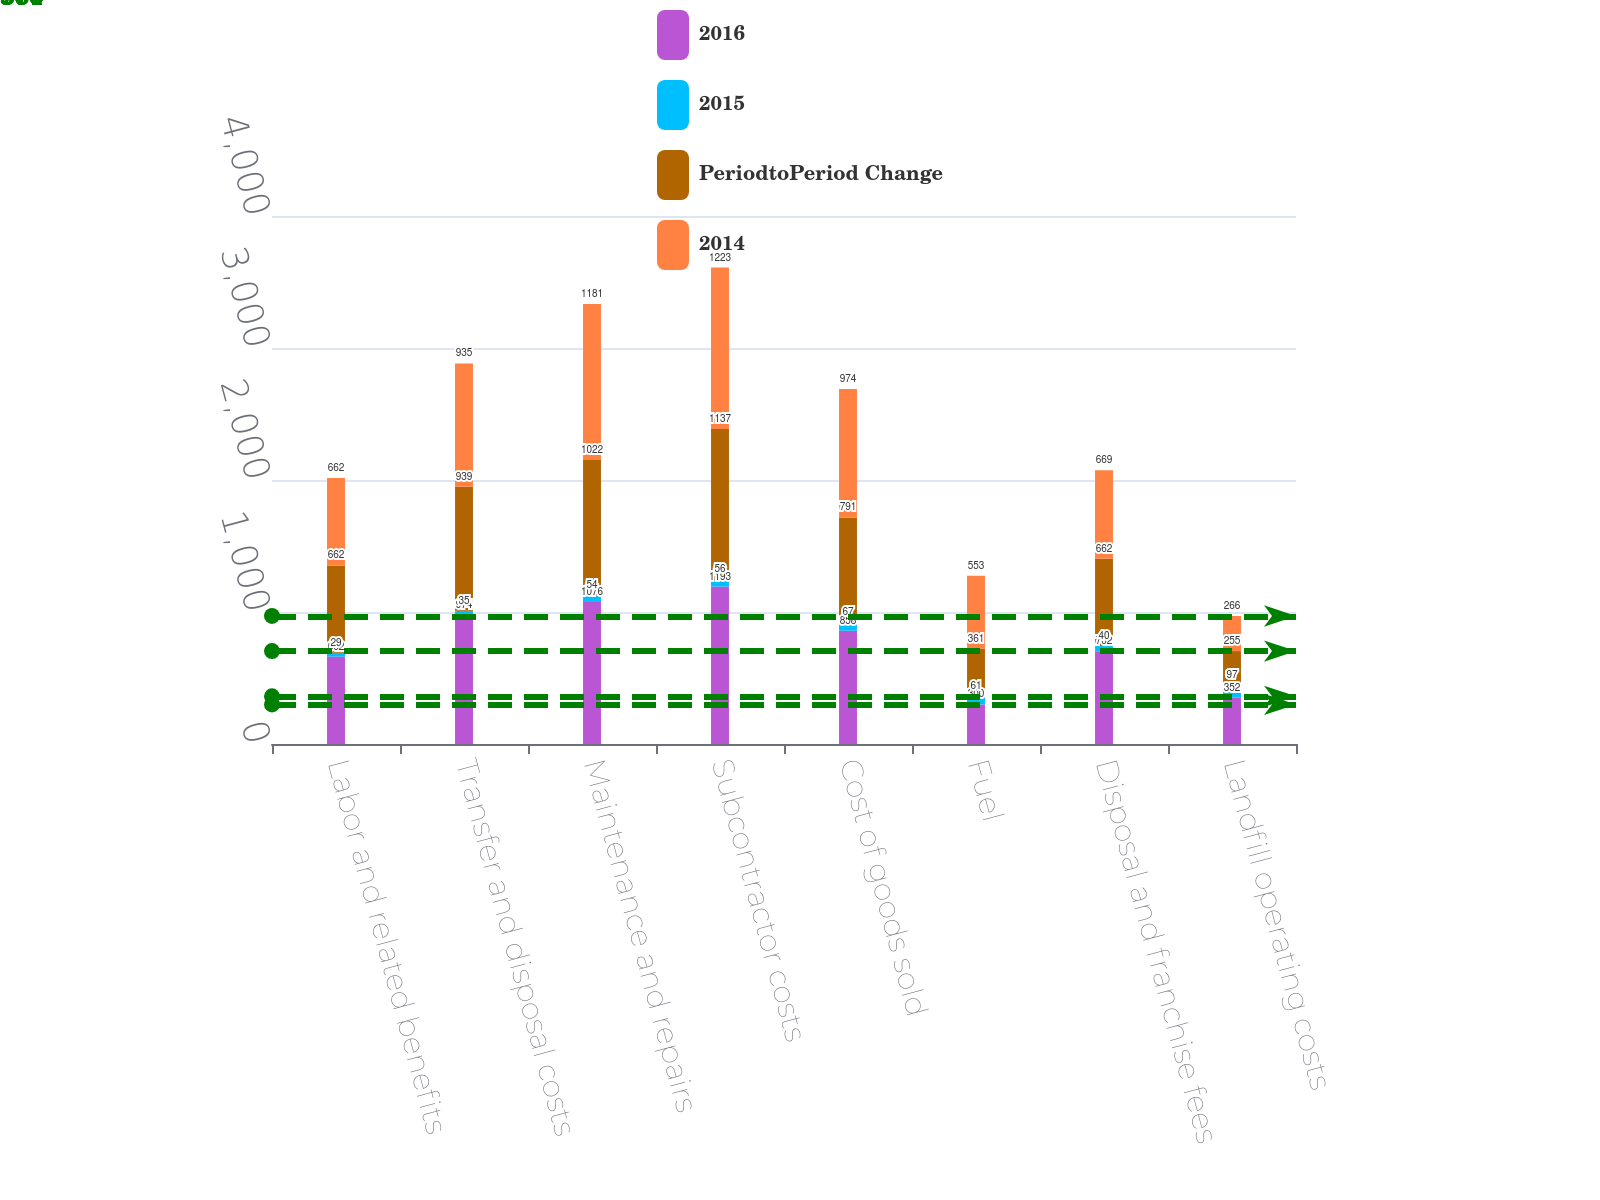Convert chart to OTSL. <chart><loc_0><loc_0><loc_500><loc_500><stacked_bar_chart><ecel><fcel>Labor and related benefits<fcel>Transfer and disposal costs<fcel>Maintenance and repairs<fcel>Subcontractor costs<fcel>Cost of goods sold<fcel>Fuel<fcel>Disposal and franchise fees<fcel>Landfill operating costs<nl><fcel>2016<fcel>662<fcel>974<fcel>1076<fcel>1193<fcel>858<fcel>300<fcel>702<fcel>352<nl><fcel>2015<fcel>29<fcel>35<fcel>54<fcel>56<fcel>67<fcel>61<fcel>40<fcel>97<nl><fcel>PeriodtoPeriod Change<fcel>662<fcel>939<fcel>1022<fcel>1137<fcel>791<fcel>361<fcel>662<fcel>255<nl><fcel>2014<fcel>662<fcel>935<fcel>1181<fcel>1223<fcel>974<fcel>553<fcel>669<fcel>266<nl></chart> 